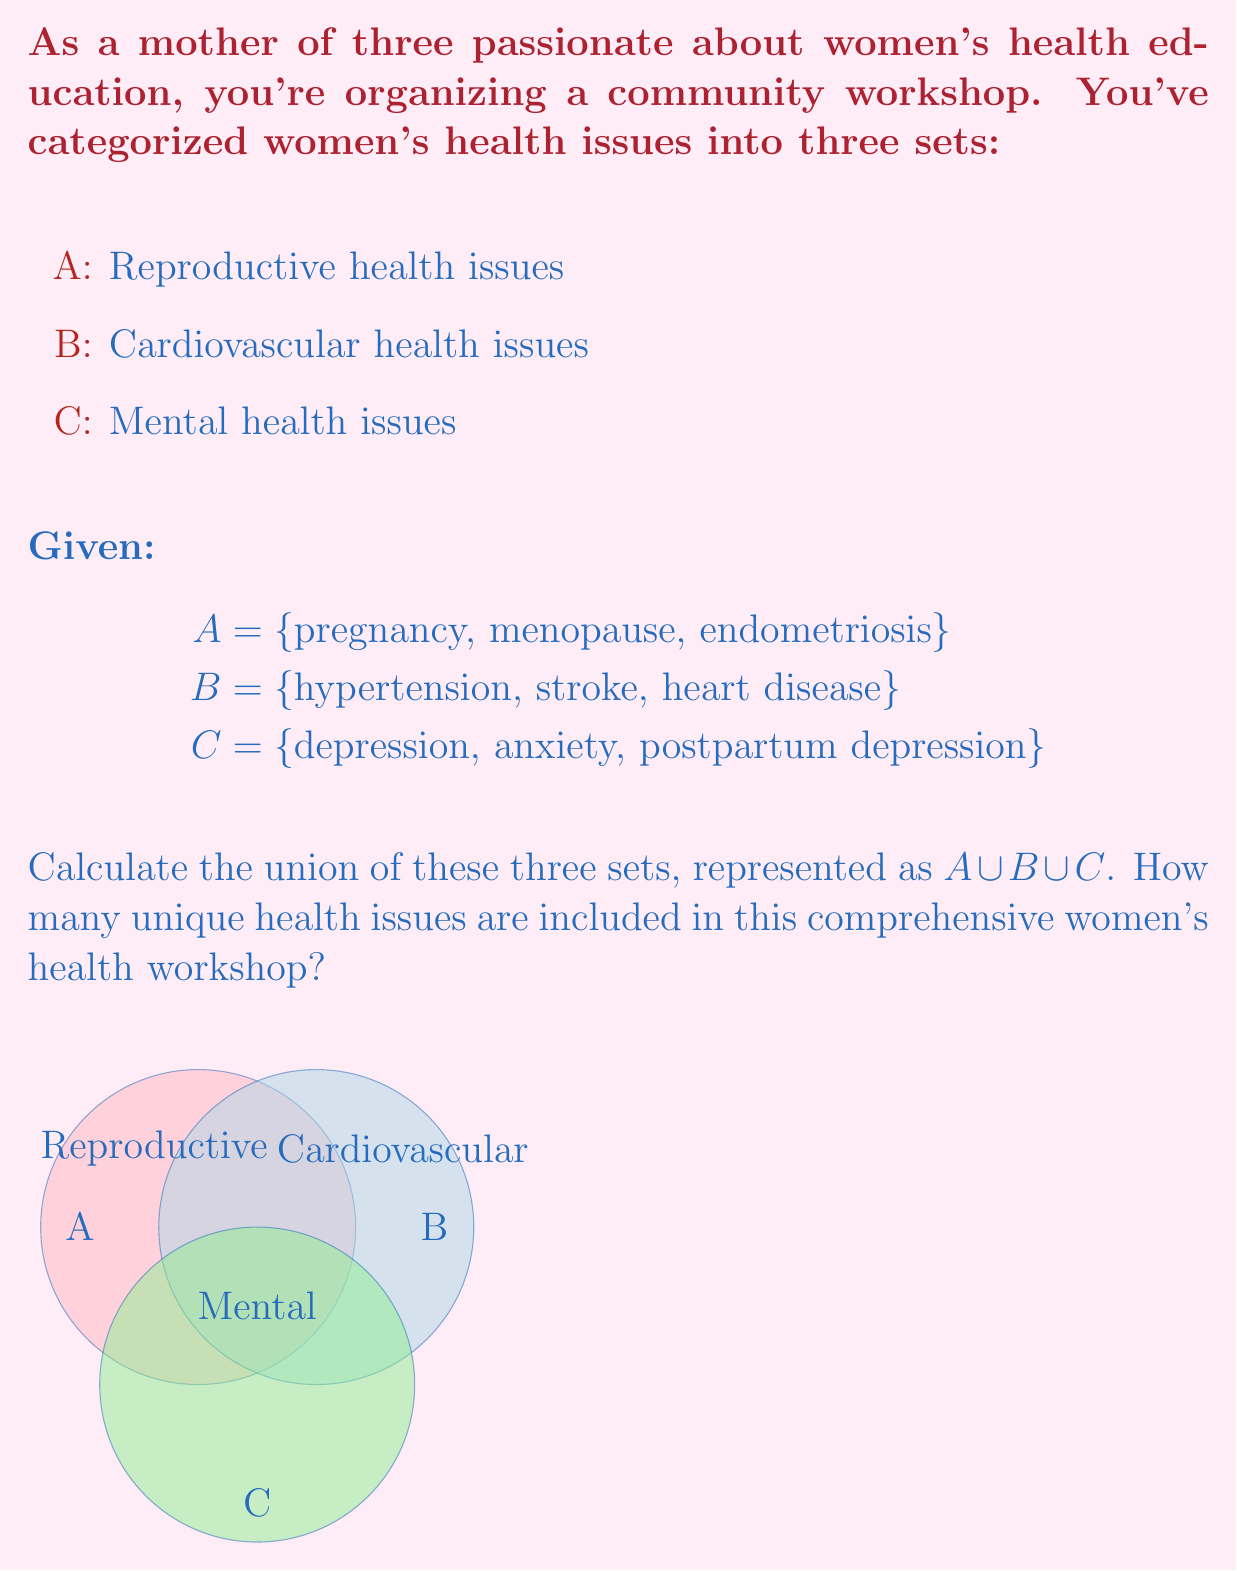Solve this math problem. To solve this problem, we need to find the union of sets A, B, and C. The union of sets includes all unique elements from all sets involved. Let's approach this step-by-step:

1) First, let's list out all the elements in each set:
   A = {pregnancy, menopause, endometriosis}
   B = {hypertension, stroke, heart disease}
   C = {depression, anxiety, postpartum depression}

2) Now, we need to combine all these elements, but we only count each element once, even if it appears in multiple sets. In this case, there are no overlapping elements between the sets.

3) The union operation is represented mathematically as:
   $A \cup B \cup C$

4) This means we include all elements from A, then add any elements from B that aren't already included, and finally add any elements from C that aren't already included.

5) Counting the unique elements:
   From A: 3 elements
   From B: 3 new elements
   From C: 3 new elements

6) Total number of unique elements: 3 + 3 + 3 = 9

Therefore, the union of these three sets contains 9 unique women's health issues that will be covered in the comprehensive workshop.
Answer: 9 unique health issues 